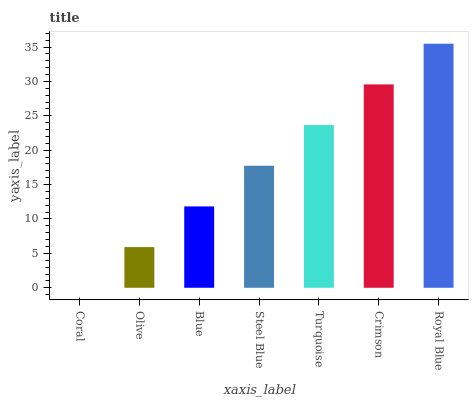Is Coral the minimum?
Answer yes or no. Yes. Is Royal Blue the maximum?
Answer yes or no. Yes. Is Olive the minimum?
Answer yes or no. No. Is Olive the maximum?
Answer yes or no. No. Is Olive greater than Coral?
Answer yes or no. Yes. Is Coral less than Olive?
Answer yes or no. Yes. Is Coral greater than Olive?
Answer yes or no. No. Is Olive less than Coral?
Answer yes or no. No. Is Steel Blue the high median?
Answer yes or no. Yes. Is Steel Blue the low median?
Answer yes or no. Yes. Is Crimson the high median?
Answer yes or no. No. Is Crimson the low median?
Answer yes or no. No. 